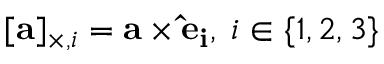<formula> <loc_0><loc_0><loc_500><loc_500>[ a ] _ { \times , i } = a \times { \hat { e } } _ { i } , \, i \in \{ 1 , 2 , 3 \}</formula> 